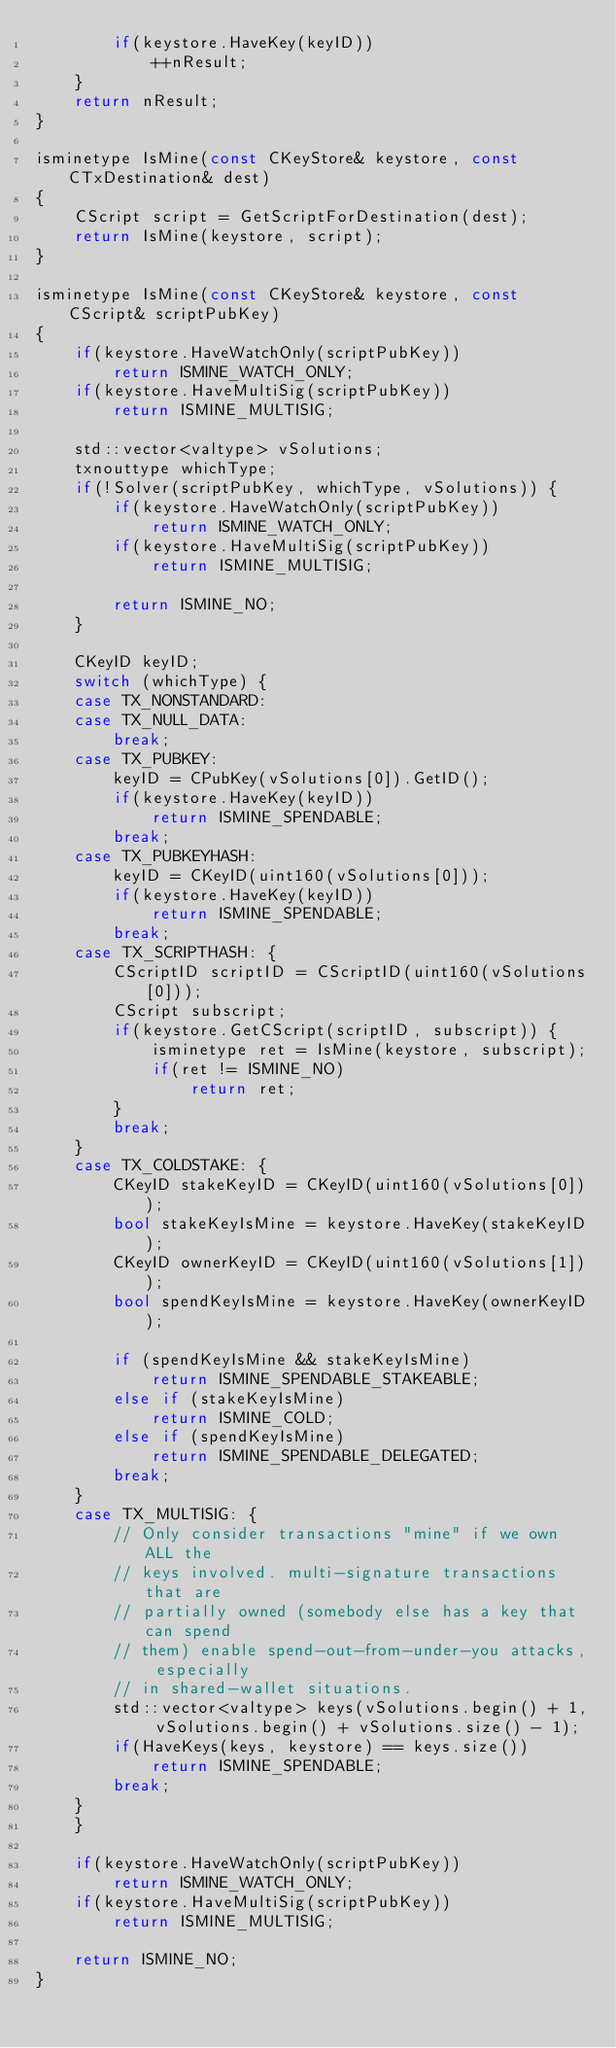<code> <loc_0><loc_0><loc_500><loc_500><_C++_>        if(keystore.HaveKey(keyID))
            ++nResult;
    }
    return nResult;
}

isminetype IsMine(const CKeyStore& keystore, const CTxDestination& dest)
{
    CScript script = GetScriptForDestination(dest);
    return IsMine(keystore, script);
}

isminetype IsMine(const CKeyStore& keystore, const CScript& scriptPubKey)
{
    if(keystore.HaveWatchOnly(scriptPubKey))
        return ISMINE_WATCH_ONLY;
    if(keystore.HaveMultiSig(scriptPubKey))
        return ISMINE_MULTISIG;

    std::vector<valtype> vSolutions;
    txnouttype whichType;
    if(!Solver(scriptPubKey, whichType, vSolutions)) {
        if(keystore.HaveWatchOnly(scriptPubKey))
            return ISMINE_WATCH_ONLY;
        if(keystore.HaveMultiSig(scriptPubKey))
            return ISMINE_MULTISIG;

        return ISMINE_NO;
    }

    CKeyID keyID;
    switch (whichType) {
    case TX_NONSTANDARD:
    case TX_NULL_DATA:
        break;
    case TX_PUBKEY:
        keyID = CPubKey(vSolutions[0]).GetID();
        if(keystore.HaveKey(keyID))
            return ISMINE_SPENDABLE;
        break;
    case TX_PUBKEYHASH:
        keyID = CKeyID(uint160(vSolutions[0]));
        if(keystore.HaveKey(keyID))
            return ISMINE_SPENDABLE;
        break;
    case TX_SCRIPTHASH: {
        CScriptID scriptID = CScriptID(uint160(vSolutions[0]));
        CScript subscript;
        if(keystore.GetCScript(scriptID, subscript)) {
            isminetype ret = IsMine(keystore, subscript);
            if(ret != ISMINE_NO)
                return ret;
        }
        break;
    }
    case TX_COLDSTAKE: {
        CKeyID stakeKeyID = CKeyID(uint160(vSolutions[0]));
        bool stakeKeyIsMine = keystore.HaveKey(stakeKeyID);
        CKeyID ownerKeyID = CKeyID(uint160(vSolutions[1]));
        bool spendKeyIsMine = keystore.HaveKey(ownerKeyID);

        if (spendKeyIsMine && stakeKeyIsMine)
            return ISMINE_SPENDABLE_STAKEABLE;
        else if (stakeKeyIsMine)
            return ISMINE_COLD;
        else if (spendKeyIsMine)
            return ISMINE_SPENDABLE_DELEGATED;
        break;
    }
    case TX_MULTISIG: {
        // Only consider transactions "mine" if we own ALL the
        // keys involved. multi-signature transactions that are
        // partially owned (somebody else has a key that can spend
        // them) enable spend-out-from-under-you attacks, especially
        // in shared-wallet situations.
        std::vector<valtype> keys(vSolutions.begin() + 1, vSolutions.begin() + vSolutions.size() - 1);
        if(HaveKeys(keys, keystore) == keys.size())
            return ISMINE_SPENDABLE;
        break;
    }
    }

    if(keystore.HaveWatchOnly(scriptPubKey))
        return ISMINE_WATCH_ONLY;
    if(keystore.HaveMultiSig(scriptPubKey))
        return ISMINE_MULTISIG;

    return ISMINE_NO;
}
</code> 